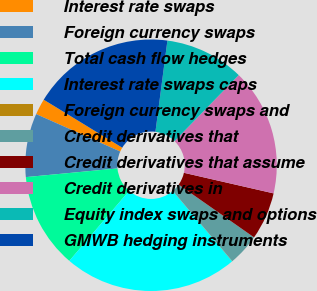Convert chart to OTSL. <chart><loc_0><loc_0><loc_500><loc_500><pie_chart><fcel>Interest rate swaps<fcel>Foreign currency swaps<fcel>Total cash flow hedges<fcel>Interest rate swaps caps<fcel>Foreign currency swaps and<fcel>Credit derivatives that<fcel>Credit derivatives that assume<fcel>Credit derivatives in<fcel>Equity index swaps and options<fcel>GMWB hedging instruments<nl><fcel>2.06%<fcel>8.17%<fcel>12.24%<fcel>22.42%<fcel>0.02%<fcel>4.09%<fcel>6.13%<fcel>16.31%<fcel>10.2%<fcel>18.35%<nl></chart> 